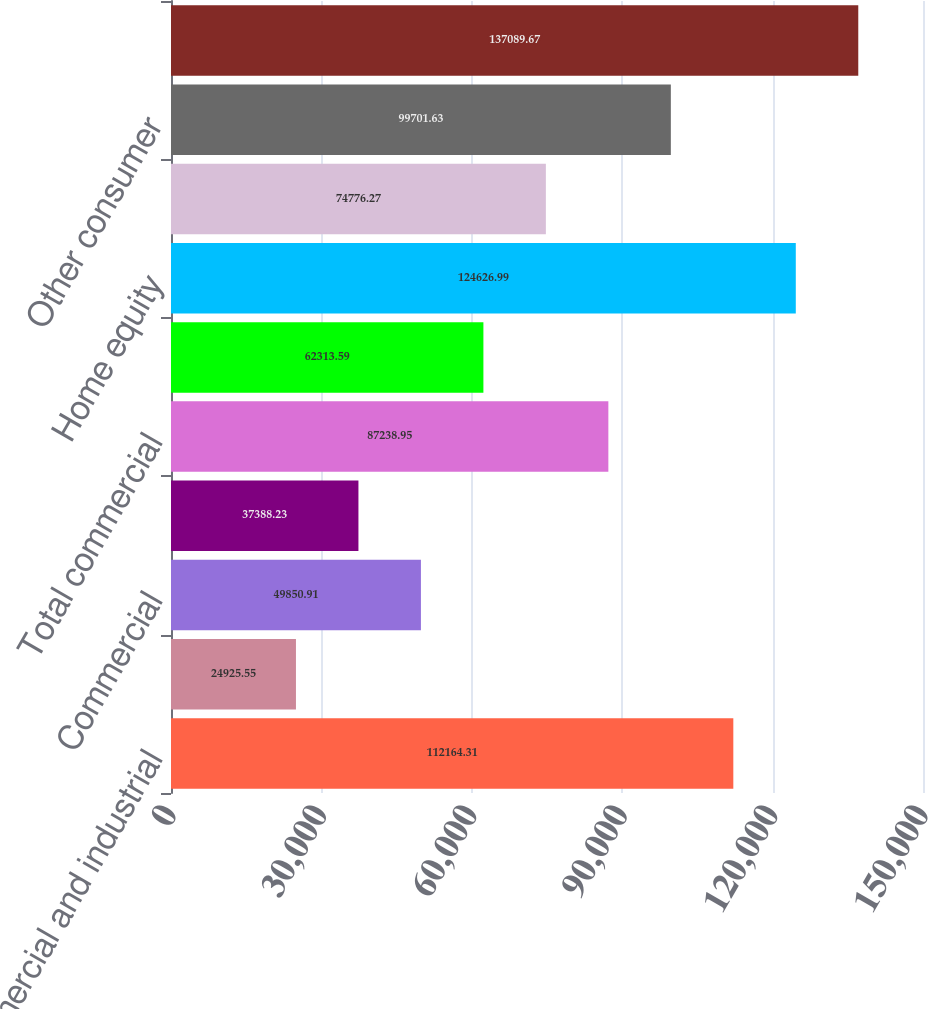Convert chart. <chart><loc_0><loc_0><loc_500><loc_500><bar_chart><fcel>Commercial and industrial<fcel>Construction<fcel>Commercial<fcel>Total commercial real estate<fcel>Total commercial<fcel>Automobile<fcel>Home equity<fcel>Residential mortgage<fcel>Other consumer<fcel>Total consumer<nl><fcel>112164<fcel>24925.5<fcel>49850.9<fcel>37388.2<fcel>87238.9<fcel>62313.6<fcel>124627<fcel>74776.3<fcel>99701.6<fcel>137090<nl></chart> 